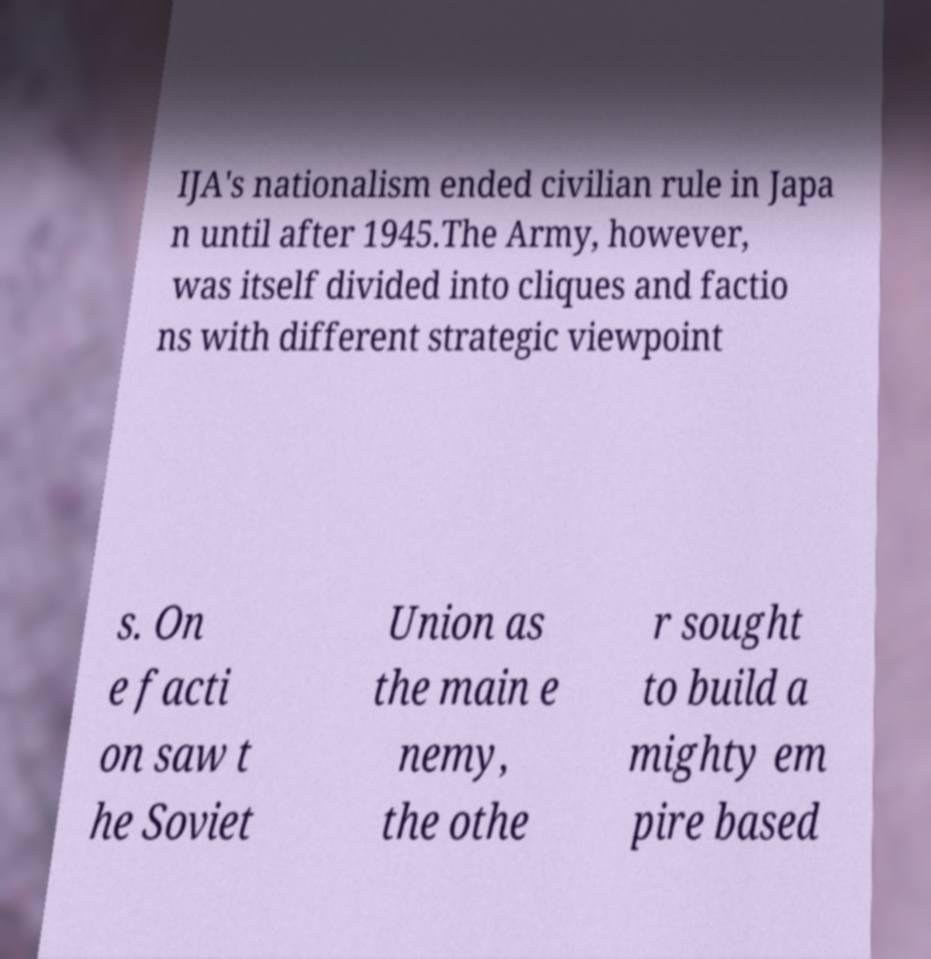Can you accurately transcribe the text from the provided image for me? IJA's nationalism ended civilian rule in Japa n until after 1945.The Army, however, was itself divided into cliques and factio ns with different strategic viewpoint s. On e facti on saw t he Soviet Union as the main e nemy, the othe r sought to build a mighty em pire based 